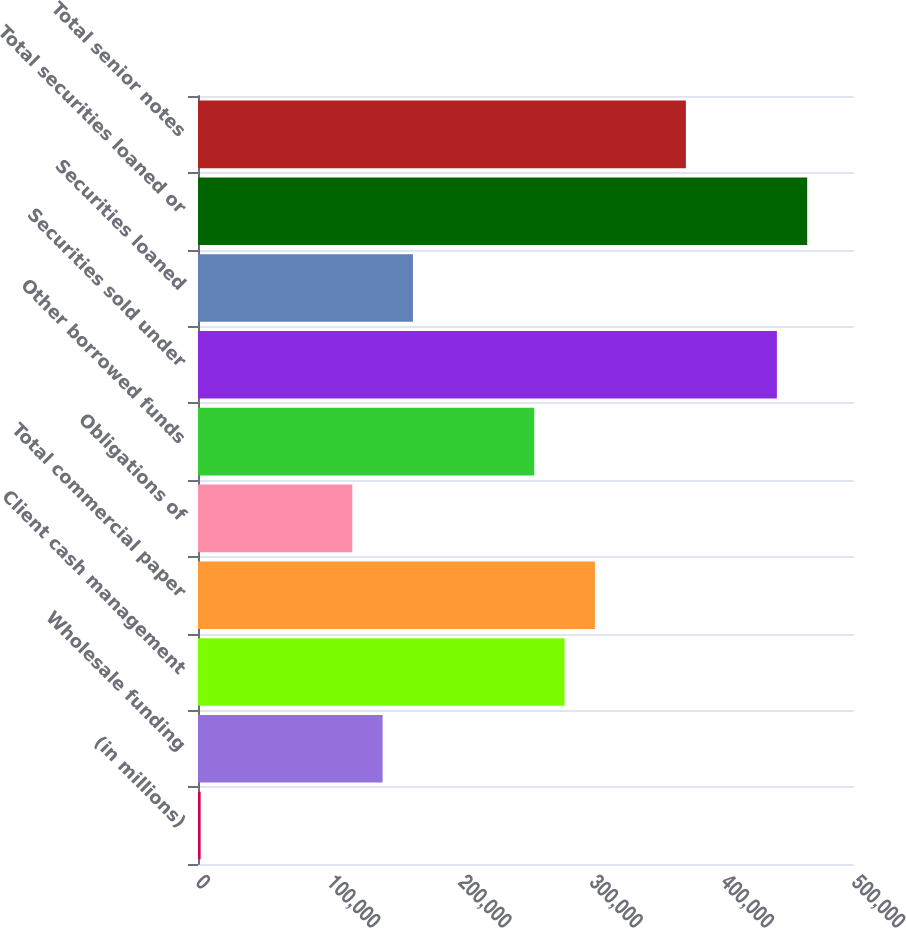Convert chart to OTSL. <chart><loc_0><loc_0><loc_500><loc_500><bar_chart><fcel>(in millions)<fcel>Wholesale funding<fcel>Client cash management<fcel>Total commercial paper<fcel>Obligations of<fcel>Other borrowed funds<fcel>Securities sold under<fcel>Securities loaned<fcel>Total securities loaned or<fcel>Total senior notes<nl><fcel>2013<fcel>140710<fcel>279406<fcel>302522<fcel>117594<fcel>256290<fcel>441219<fcel>163826<fcel>464335<fcel>371871<nl></chart> 